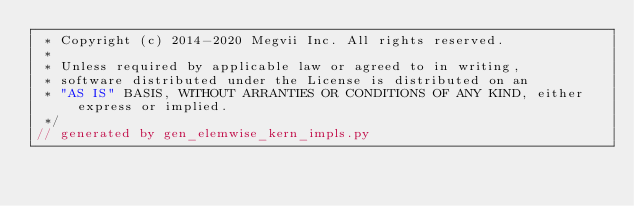Convert code to text. <code><loc_0><loc_0><loc_500><loc_500><_Cuda_> * Copyright (c) 2014-2020 Megvii Inc. All rights reserved.
 *
 * Unless required by applicable law or agreed to in writing,
 * software distributed under the License is distributed on an
 * "AS IS" BASIS, WITHOUT ARRANTIES OR CONDITIONS OF ANY KIND, either express or implied.
 */
// generated by gen_elemwise_kern_impls.py</code> 